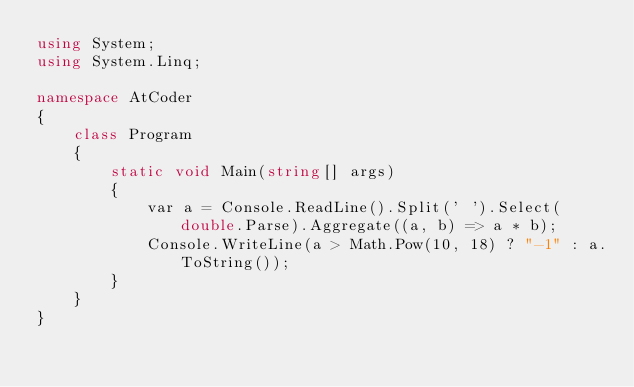<code> <loc_0><loc_0><loc_500><loc_500><_C#_>using System;
using System.Linq;

namespace AtCoder
{
    class Program
    {
        static void Main(string[] args)
        {
            var a = Console.ReadLine().Split(' ').Select(double.Parse).Aggregate((a, b) => a * b);
            Console.WriteLine(a > Math.Pow(10, 18) ? "-1" : a.ToString());
        }
    }
}
</code> 